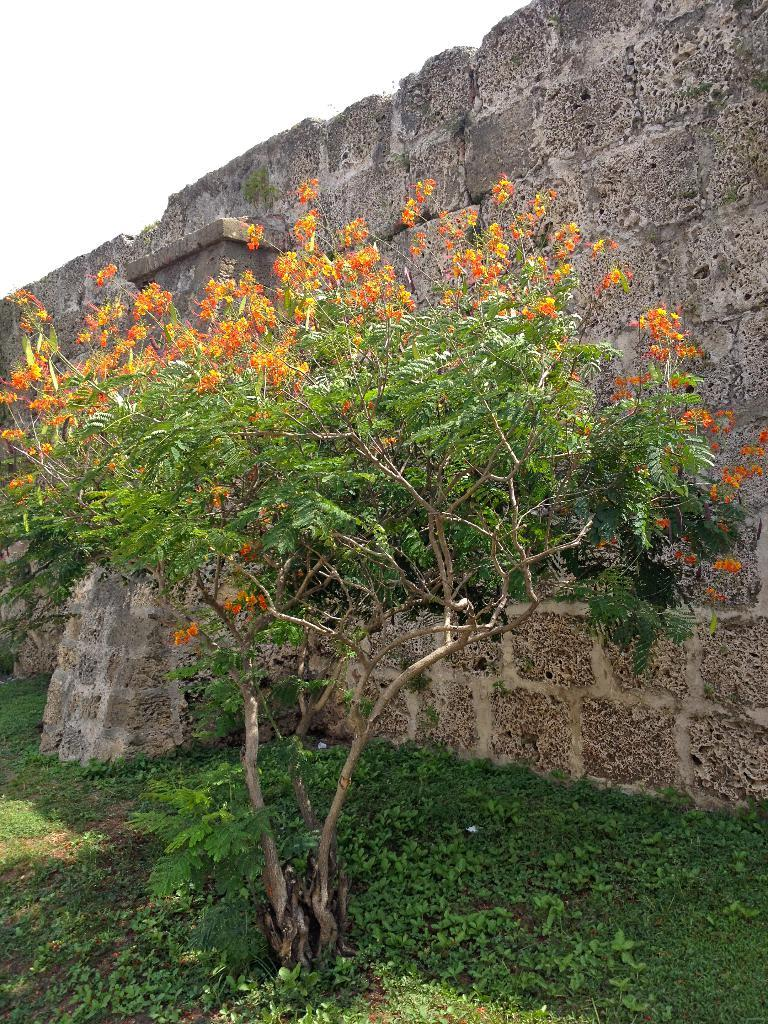What type of vegetation is present in the image? There is a tree and small plants on the ground in the image. What structure can be seen from left to right in the image? A wall is visible from left to right in the image. How many kittens are sitting on the stove in the image? There are no kittens or stoves present in the image. What type of organization is responsible for maintaining the plants in the image? There is no information about any organization responsible for maintaining the plants in the image. 